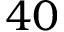<formula> <loc_0><loc_0><loc_500><loc_500>4 0</formula> 